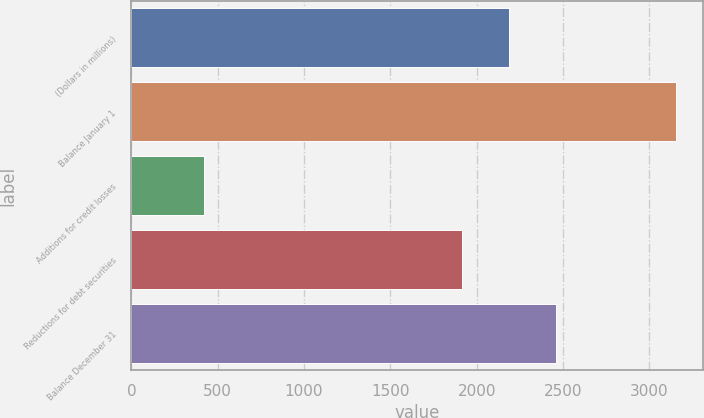Convert chart. <chart><loc_0><loc_0><loc_500><loc_500><bar_chart><fcel>(Dollars in millions)<fcel>Balance January 1<fcel>Additions for credit losses<fcel>Reductions for debt securities<fcel>Balance December 31<nl><fcel>2188.4<fcel>3155<fcel>421<fcel>1915<fcel>2461.8<nl></chart> 